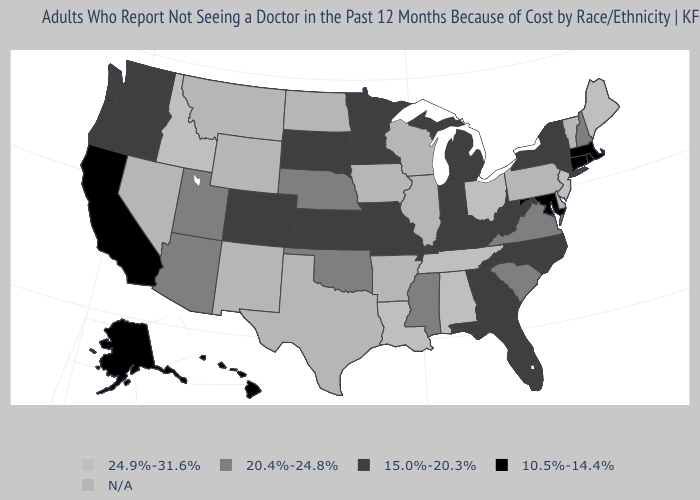What is the value of New Jersey?
Write a very short answer. 24.9%-31.6%. Is the legend a continuous bar?
Short answer required. No. What is the lowest value in the West?
Short answer required. 10.5%-14.4%. Name the states that have a value in the range N/A?
Answer briefly. Arkansas, Delaware, Illinois, Iowa, Montana, Nevada, New Mexico, North Dakota, Pennsylvania, Texas, Vermont, Wisconsin, Wyoming. Name the states that have a value in the range 20.4%-24.8%?
Quick response, please. Arizona, Mississippi, Nebraska, New Hampshire, Oklahoma, South Carolina, Utah, Virginia. Does Connecticut have the lowest value in the USA?
Quick response, please. Yes. Does Idaho have the lowest value in the USA?
Short answer required. No. What is the lowest value in the Northeast?
Write a very short answer. 10.5%-14.4%. What is the value of Oregon?
Answer briefly. 15.0%-20.3%. What is the value of Utah?
Quick response, please. 20.4%-24.8%. What is the value of Oklahoma?
Be succinct. 20.4%-24.8%. 